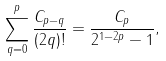Convert formula to latex. <formula><loc_0><loc_0><loc_500><loc_500>\sum _ { q = 0 } ^ { p } \frac { C _ { p - q } } { ( 2 q ) ! } = \frac { C _ { p } } { 2 ^ { 1 - 2 p } - 1 } ,</formula> 